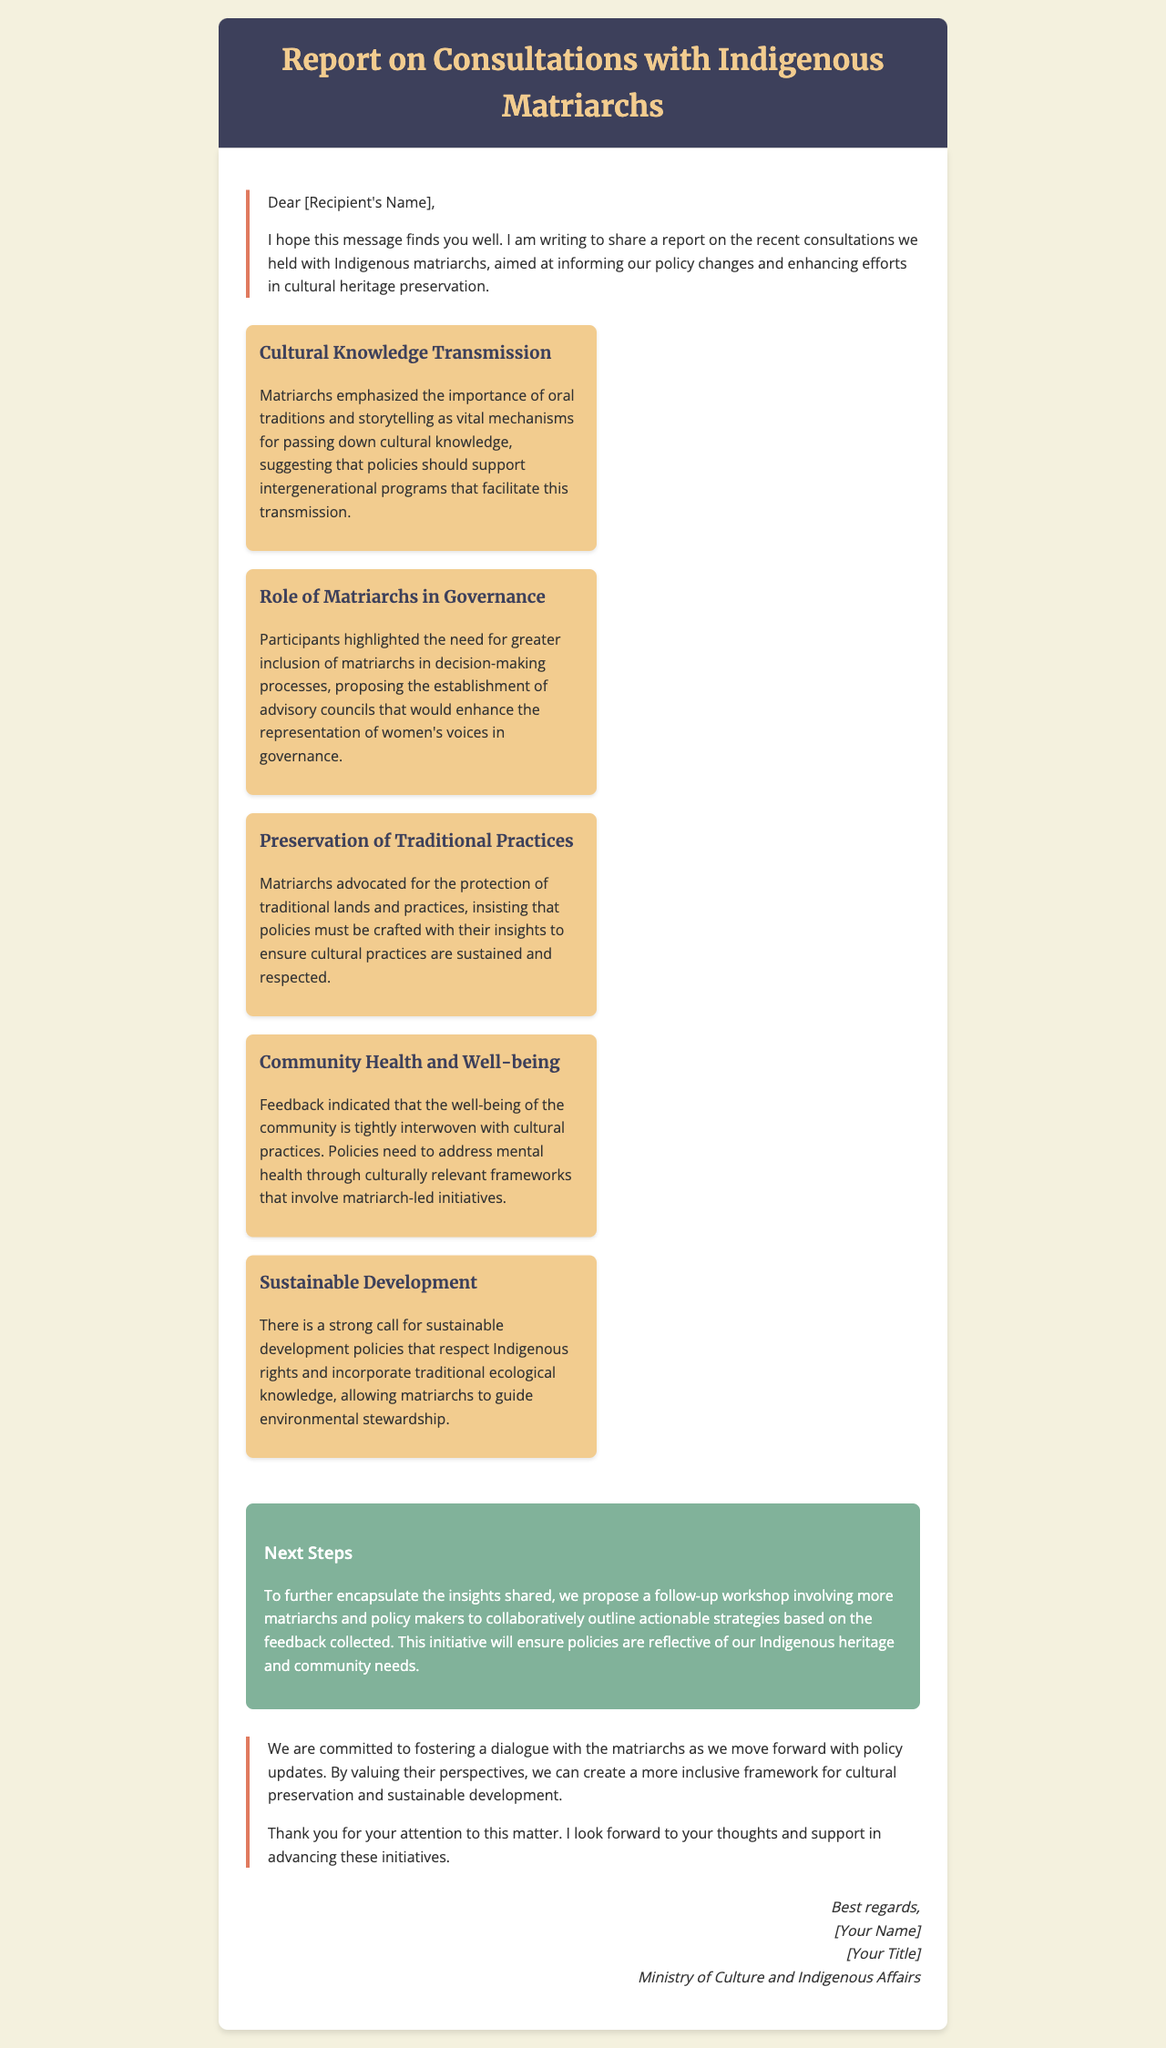What is the main purpose of the report? The report aims to inform policy changes and enhance efforts in cultural heritage preservation based on consultations with Indigenous matriarchs.
Answer: Inform policy changes and enhance efforts in cultural heritage preservation Who emphasized the importance of oral traditions? Matriarchs are the ones who emphasized the importance of oral traditions and storytelling for passing down cultural knowledge.
Answer: Matriarchs What do the matriarchs propose for decision-making processes? They propose the establishment of advisory councils to enhance the representation of women's voices in governance.
Answer: Establish advisory councils What is a key finding related to community well-being? The well-being of the community is interwoven with cultural practices and needs to be addressed through culturally relevant frameworks.
Answer: Interwoven with cultural practices What is proposed as a next step after the consultations? A follow-up workshop involving more matriarchs and policy makers is proposed to outline actionable strategies based on feedback collected.
Answer: Follow-up workshop 